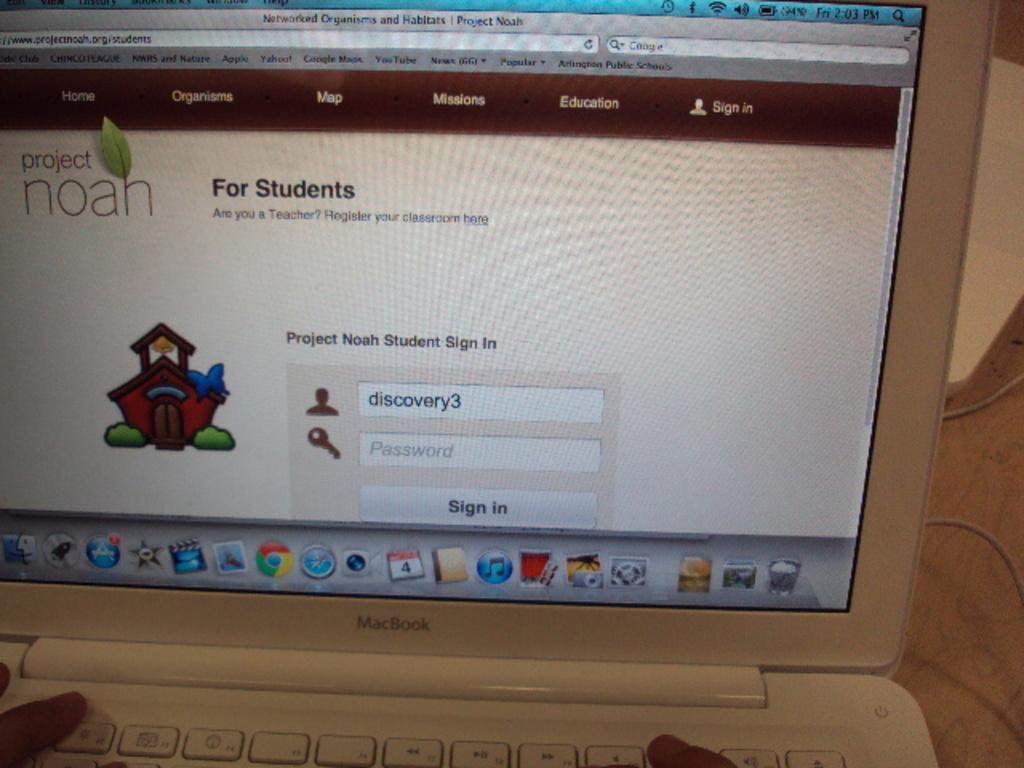What is the username on this student's sign in?
Keep it short and to the point. Discovery3. What kind of laptop is this?
Provide a short and direct response. Macbook. 